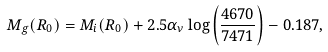<formula> <loc_0><loc_0><loc_500><loc_500>M _ { g } ( R _ { 0 } ) = M _ { i } ( R _ { 0 } ) + 2 . 5 \alpha _ { \nu } \log \left ( \frac { 4 6 7 0 { \AA } } { 7 4 7 1 { \AA } } \right ) - 0 . 1 8 7 ,</formula> 